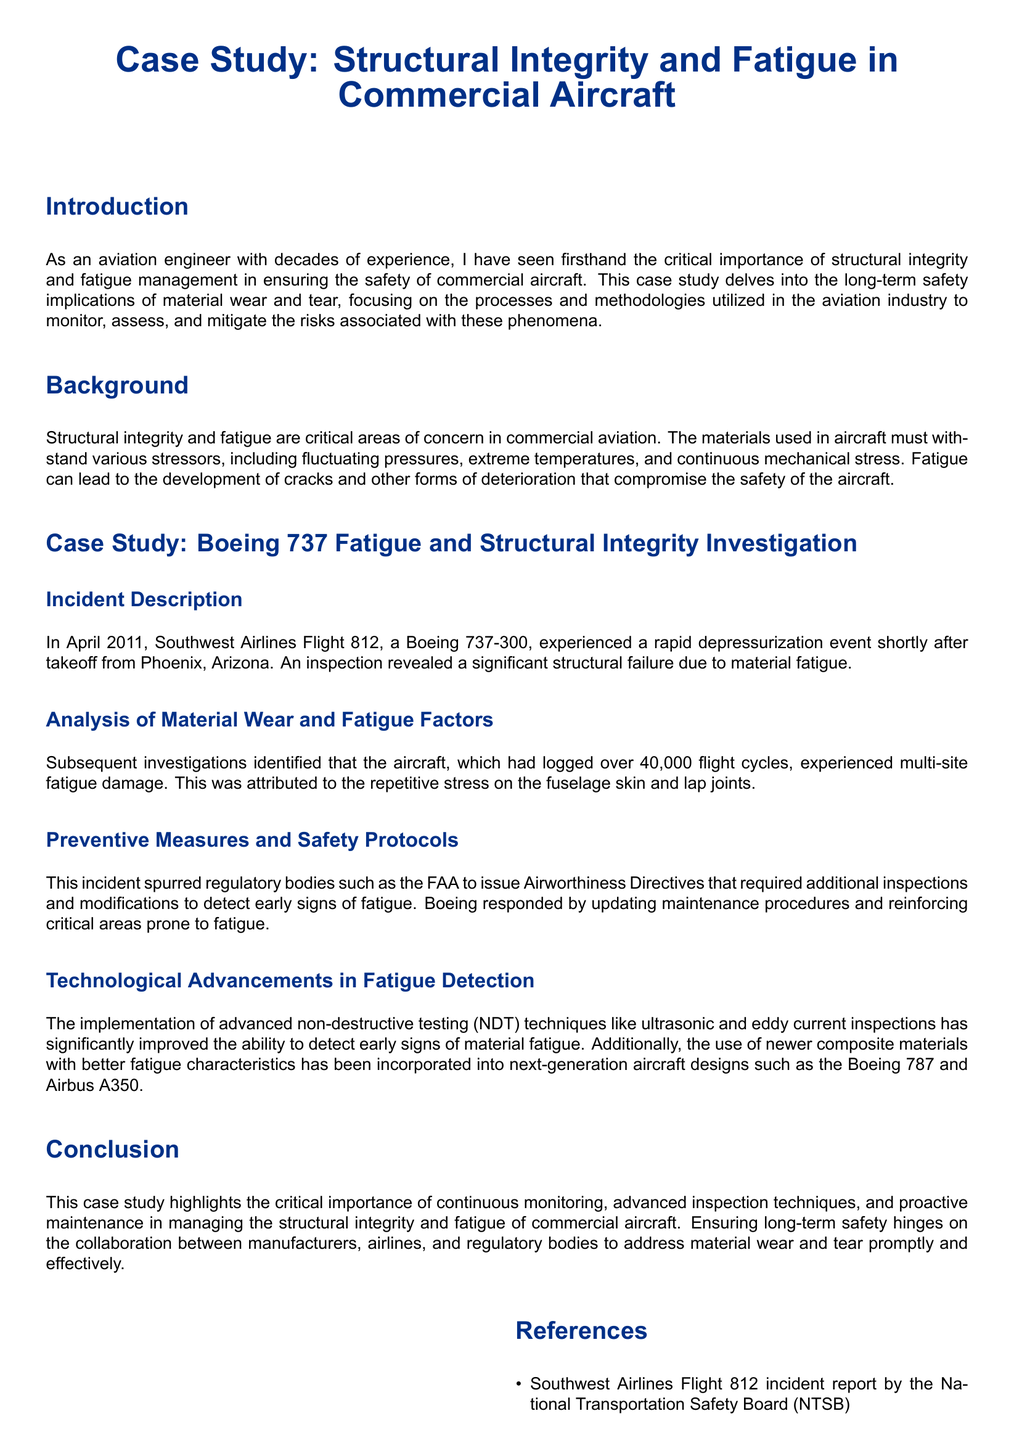What aircraft was involved in the incident? The document specifies Southwest Airlines Flight 812, a Boeing 737-300, as the aircraft involved in the incident.
Answer: Boeing 737-300 When did the incident occur? The document provides the date of the incident, which is April 2011.
Answer: April 2011 How many flight cycles had the aircraft logged? According to the analysis, the aircraft had logged over 40,000 flight cycles.
Answer: Over 40,000 What type of testing techniques were mentioned for fatigue detection? The document lists advanced non-destructive testing techniques like ultrasonic and eddy current inspections for fatigue detection.
Answer: Ultrasonic and eddy current inspections What regulatory body issued directives after the incident? The document states that the FAA issued Airworthiness Directives following the incident.
Answer: FAA What did the investigations reveal about the cause of the structural failure? Investigations identified multi-site fatigue damage as the cause of the structural failure.
Answer: Multi-site fatigue damage What is a key factor in ensuring the long-term safety of aircraft? The conclusion emphasizes the critical importance of continuous monitoring and advanced inspection techniques for long-term safety.
Answer: Continuous monitoring What safety measures were updated as a result of the incident? The document mentions the update of maintenance procedures and reinforcement of critical areas as preventive measures taken.
Answer: Maintenance procedures and reinforcement of critical areas 